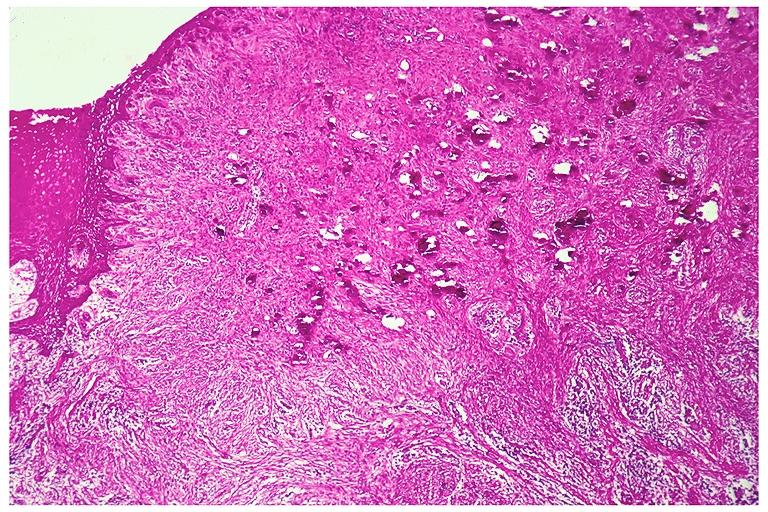where is this?
Answer the question using a single word or phrase. Oral 